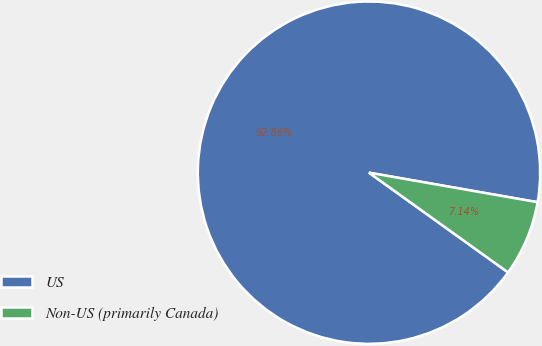Convert chart. <chart><loc_0><loc_0><loc_500><loc_500><pie_chart><fcel>US<fcel>Non-US (primarily Canada)<nl><fcel>92.86%<fcel>7.14%<nl></chart> 